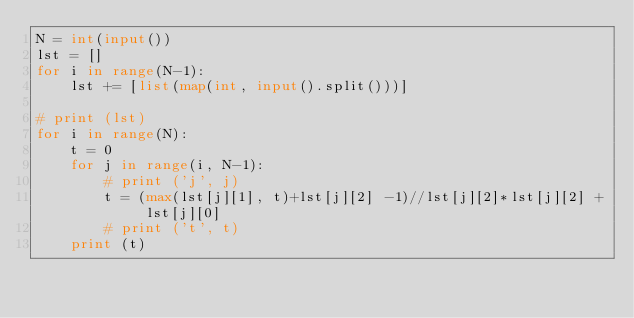<code> <loc_0><loc_0><loc_500><loc_500><_Python_>N = int(input())
lst = []
for i in range(N-1):
    lst += [list(map(int, input().split()))]

# print (lst)
for i in range(N):
    t = 0
    for j in range(i, N-1):
        # print ('j', j)
        t = (max(lst[j][1], t)+lst[j][2] -1)//lst[j][2]*lst[j][2] + lst[j][0]
        # print ('t', t)
    print (t)</code> 